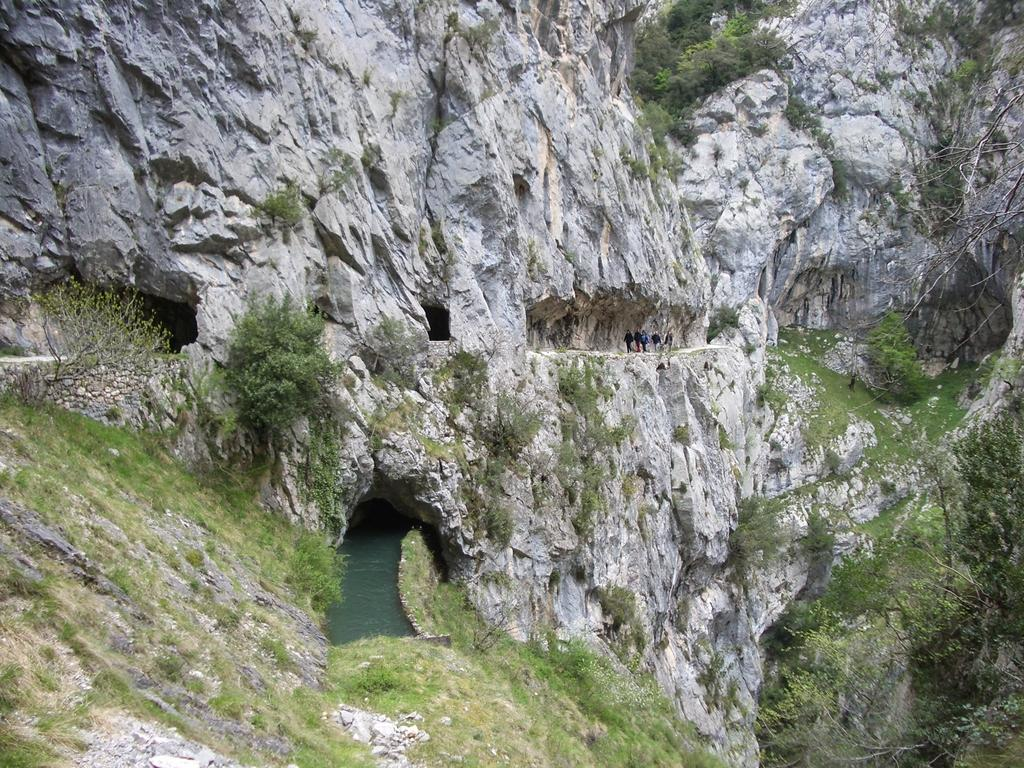What is visible in the image? There is water visible in the image. Where are the people located in the image? The people are standing on a mountain in the image. What type of vegetation can be seen in the image? There are trees and plants in the image. Can you describe the harmony between the snake and the plants in the image? There is no snake present in the image, so it is not possible to describe any harmony between a snake and the plants. 